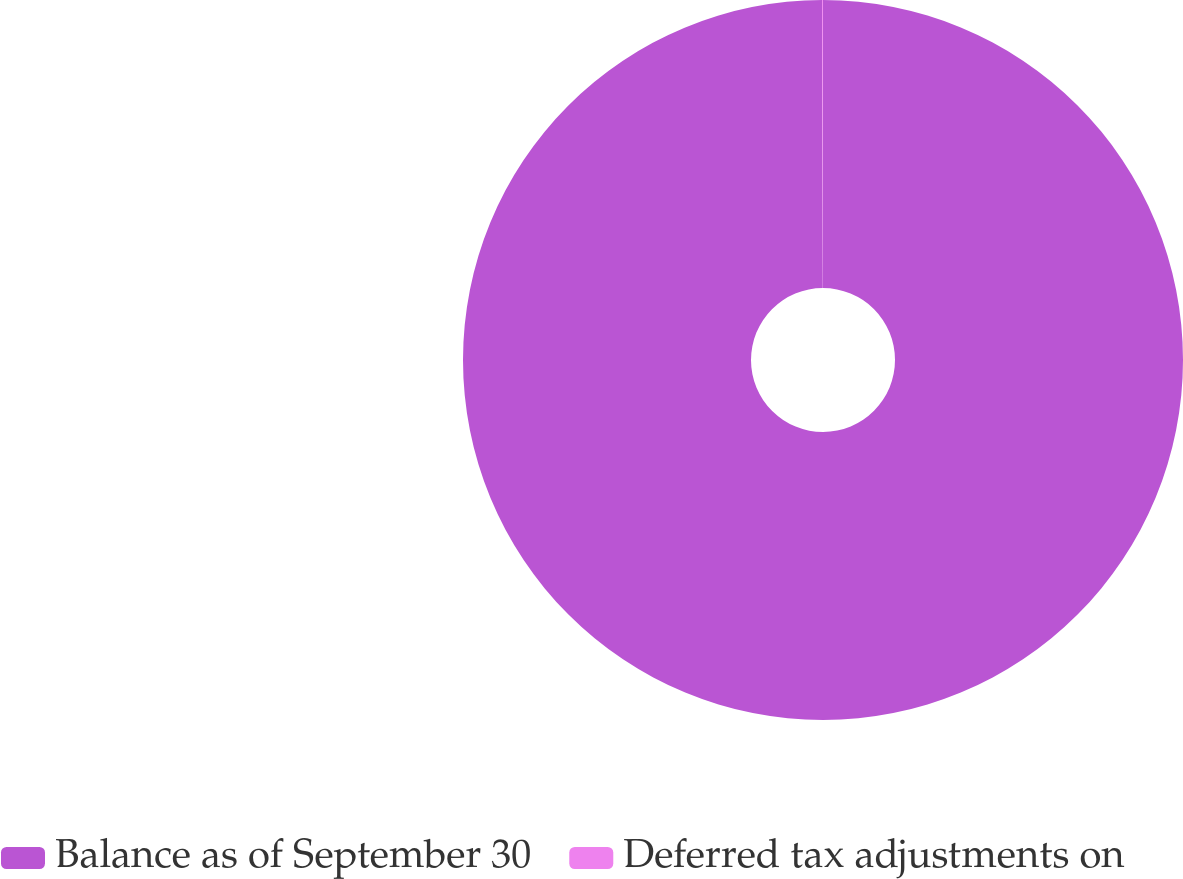Convert chart. <chart><loc_0><loc_0><loc_500><loc_500><pie_chart><fcel>Balance as of September 30<fcel>Deferred tax adjustments on<nl><fcel>99.96%<fcel>0.04%<nl></chart> 